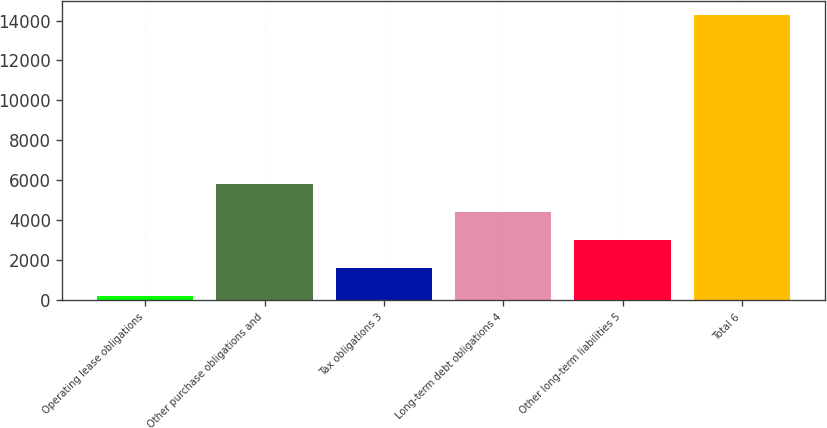<chart> <loc_0><loc_0><loc_500><loc_500><bar_chart><fcel>Operating lease obligations<fcel>Other purchase obligations and<fcel>Tax obligations 3<fcel>Long-term debt obligations 4<fcel>Other long-term liabilities 5<fcel>Total 6<nl><fcel>215<fcel>5835<fcel>1620<fcel>4430<fcel>3025<fcel>14265<nl></chart> 